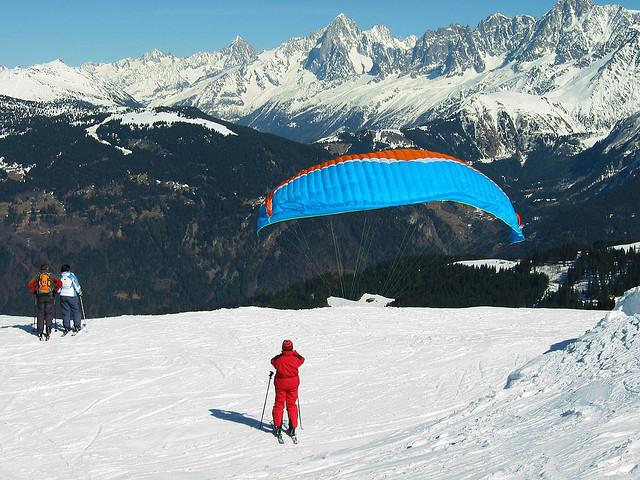Are these people on a frozen lake?
Give a very brief answer. No. What is covering the ground?
Short answer required. Snow. How many people are seen?
Write a very short answer. 3. 